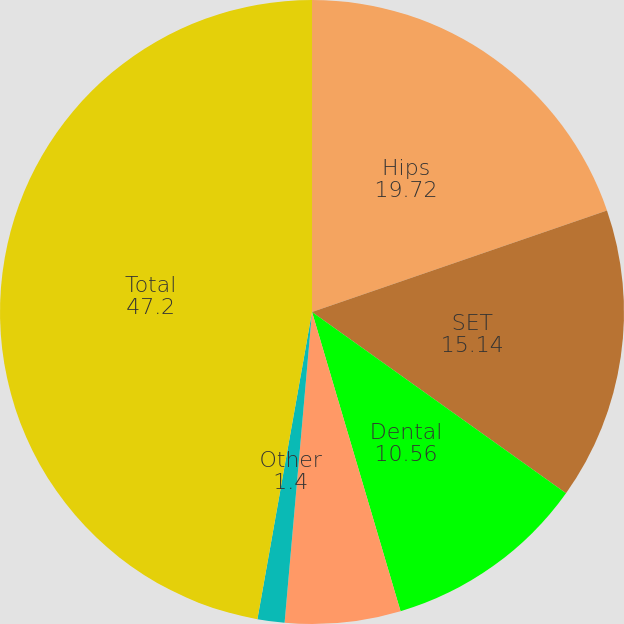<chart> <loc_0><loc_0><loc_500><loc_500><pie_chart><fcel>Hips<fcel>SET<fcel>Dental<fcel>Spine & CMF<fcel>Other<fcel>Total<nl><fcel>19.72%<fcel>15.14%<fcel>10.56%<fcel>5.98%<fcel>1.4%<fcel>47.2%<nl></chart> 